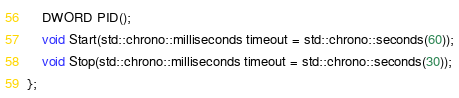<code> <loc_0><loc_0><loc_500><loc_500><_C_>
    DWORD PID();
    void Start(std::chrono::milliseconds timeout = std::chrono::seconds(60));
    void Stop(std::chrono::milliseconds timeout = std::chrono::seconds(30));
};

</code> 